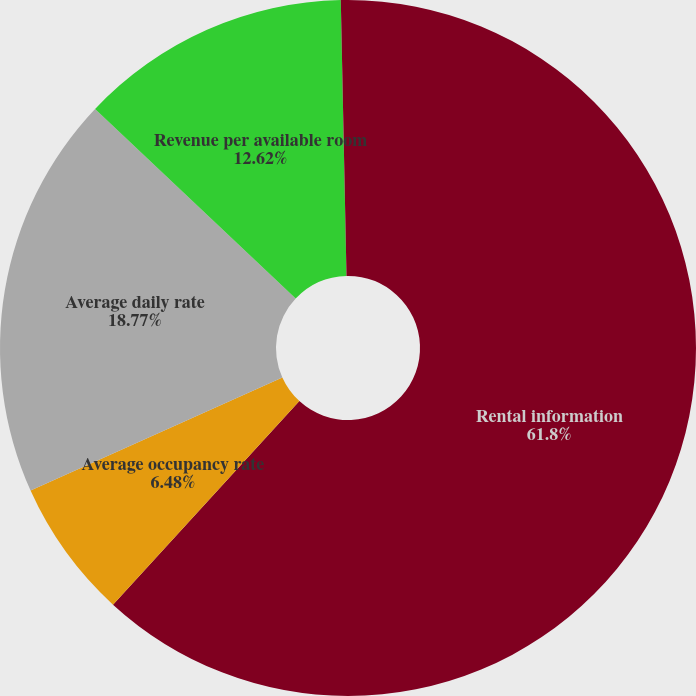Convert chart. <chart><loc_0><loc_0><loc_500><loc_500><pie_chart><fcel>Rental information<fcel>Average occupancy rate<fcel>Average daily rate<fcel>Revenue per available room<fcel>Annual rent per square feet<nl><fcel>61.8%<fcel>6.48%<fcel>18.77%<fcel>12.62%<fcel>0.33%<nl></chart> 